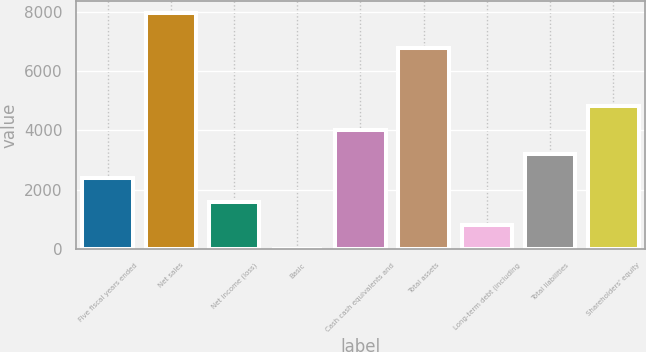Convert chart to OTSL. <chart><loc_0><loc_0><loc_500><loc_500><bar_chart><fcel>Five fiscal years ended<fcel>Net sales<fcel>Net income (loss)<fcel>Basic<fcel>Cash cash equivalents and<fcel>Total assets<fcel>Long-term debt (including<fcel>Total liabilities<fcel>Shareholders' equity<nl><fcel>2396.6<fcel>7983<fcel>1598.54<fcel>2.42<fcel>4027<fcel>6803<fcel>800.48<fcel>3194.66<fcel>4825.06<nl></chart> 